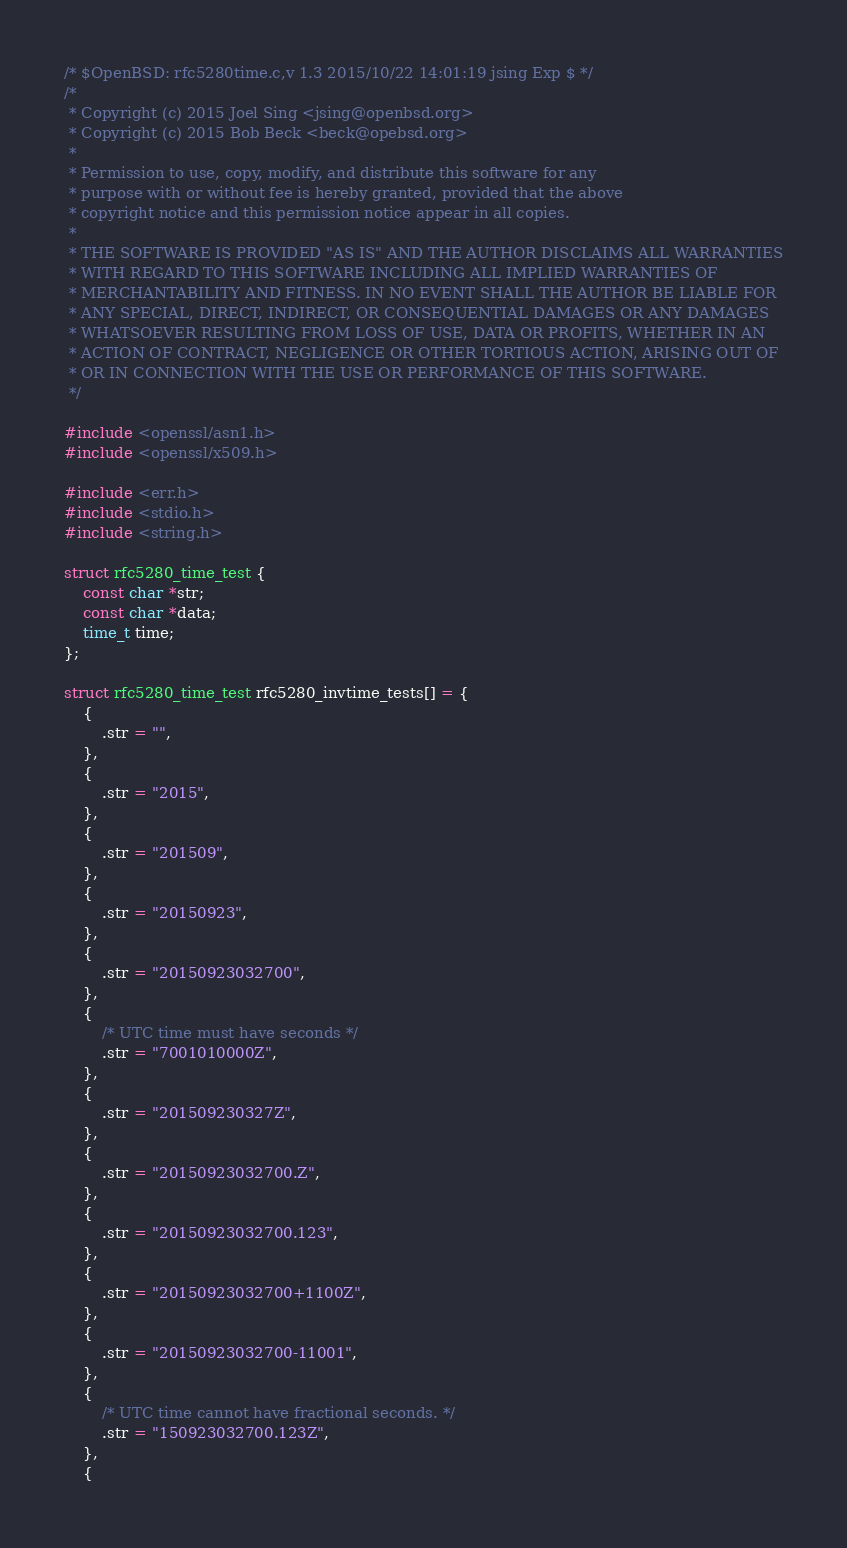Convert code to text. <code><loc_0><loc_0><loc_500><loc_500><_C_>/* $OpenBSD: rfc5280time.c,v 1.3 2015/10/22 14:01:19 jsing Exp $ */
/*
 * Copyright (c) 2015 Joel Sing <jsing@openbsd.org>
 * Copyright (c) 2015 Bob Beck <beck@opebsd.org>
 *
 * Permission to use, copy, modify, and distribute this software for any
 * purpose with or without fee is hereby granted, provided that the above
 * copyright notice and this permission notice appear in all copies.
 *
 * THE SOFTWARE IS PROVIDED "AS IS" AND THE AUTHOR DISCLAIMS ALL WARRANTIES
 * WITH REGARD TO THIS SOFTWARE INCLUDING ALL IMPLIED WARRANTIES OF
 * MERCHANTABILITY AND FITNESS. IN NO EVENT SHALL THE AUTHOR BE LIABLE FOR
 * ANY SPECIAL, DIRECT, INDIRECT, OR CONSEQUENTIAL DAMAGES OR ANY DAMAGES
 * WHATSOEVER RESULTING FROM LOSS OF USE, DATA OR PROFITS, WHETHER IN AN
 * ACTION OF CONTRACT, NEGLIGENCE OR OTHER TORTIOUS ACTION, ARISING OUT OF
 * OR IN CONNECTION WITH THE USE OR PERFORMANCE OF THIS SOFTWARE.
 */

#include <openssl/asn1.h>
#include <openssl/x509.h>

#include <err.h>
#include <stdio.h>
#include <string.h>

struct rfc5280_time_test {
	const char *str;
	const char *data;
	time_t time;
};

struct rfc5280_time_test rfc5280_invtime_tests[] = {
	{
		.str = "",
	},
	{
		.str = "2015",
	},
	{
		.str = "201509",
	},
	{
		.str = "20150923",
	},
	{
		.str = "20150923032700",
	},
	{
		/* UTC time must have seconds */
		.str = "7001010000Z",
	},
	{
		.str = "201509230327Z",
	},
	{
		.str = "20150923032700.Z",
	},
	{
		.str = "20150923032700.123",
	},
	{
		.str = "20150923032700+1100Z",
	},
	{
		.str = "20150923032700-11001",
	},
	{
		/* UTC time cannot have fractional seconds. */
		.str = "150923032700.123Z",
	},
	{</code> 